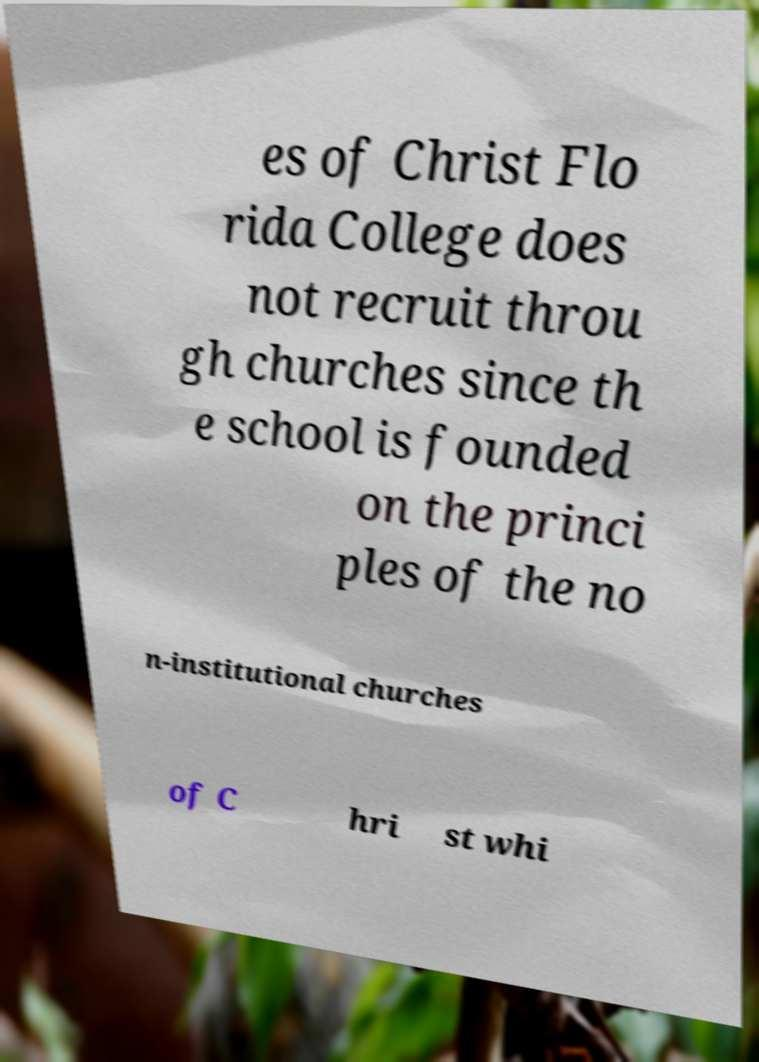I need the written content from this picture converted into text. Can you do that? es of Christ Flo rida College does not recruit throu gh churches since th e school is founded on the princi ples of the no n-institutional churches of C hri st whi 